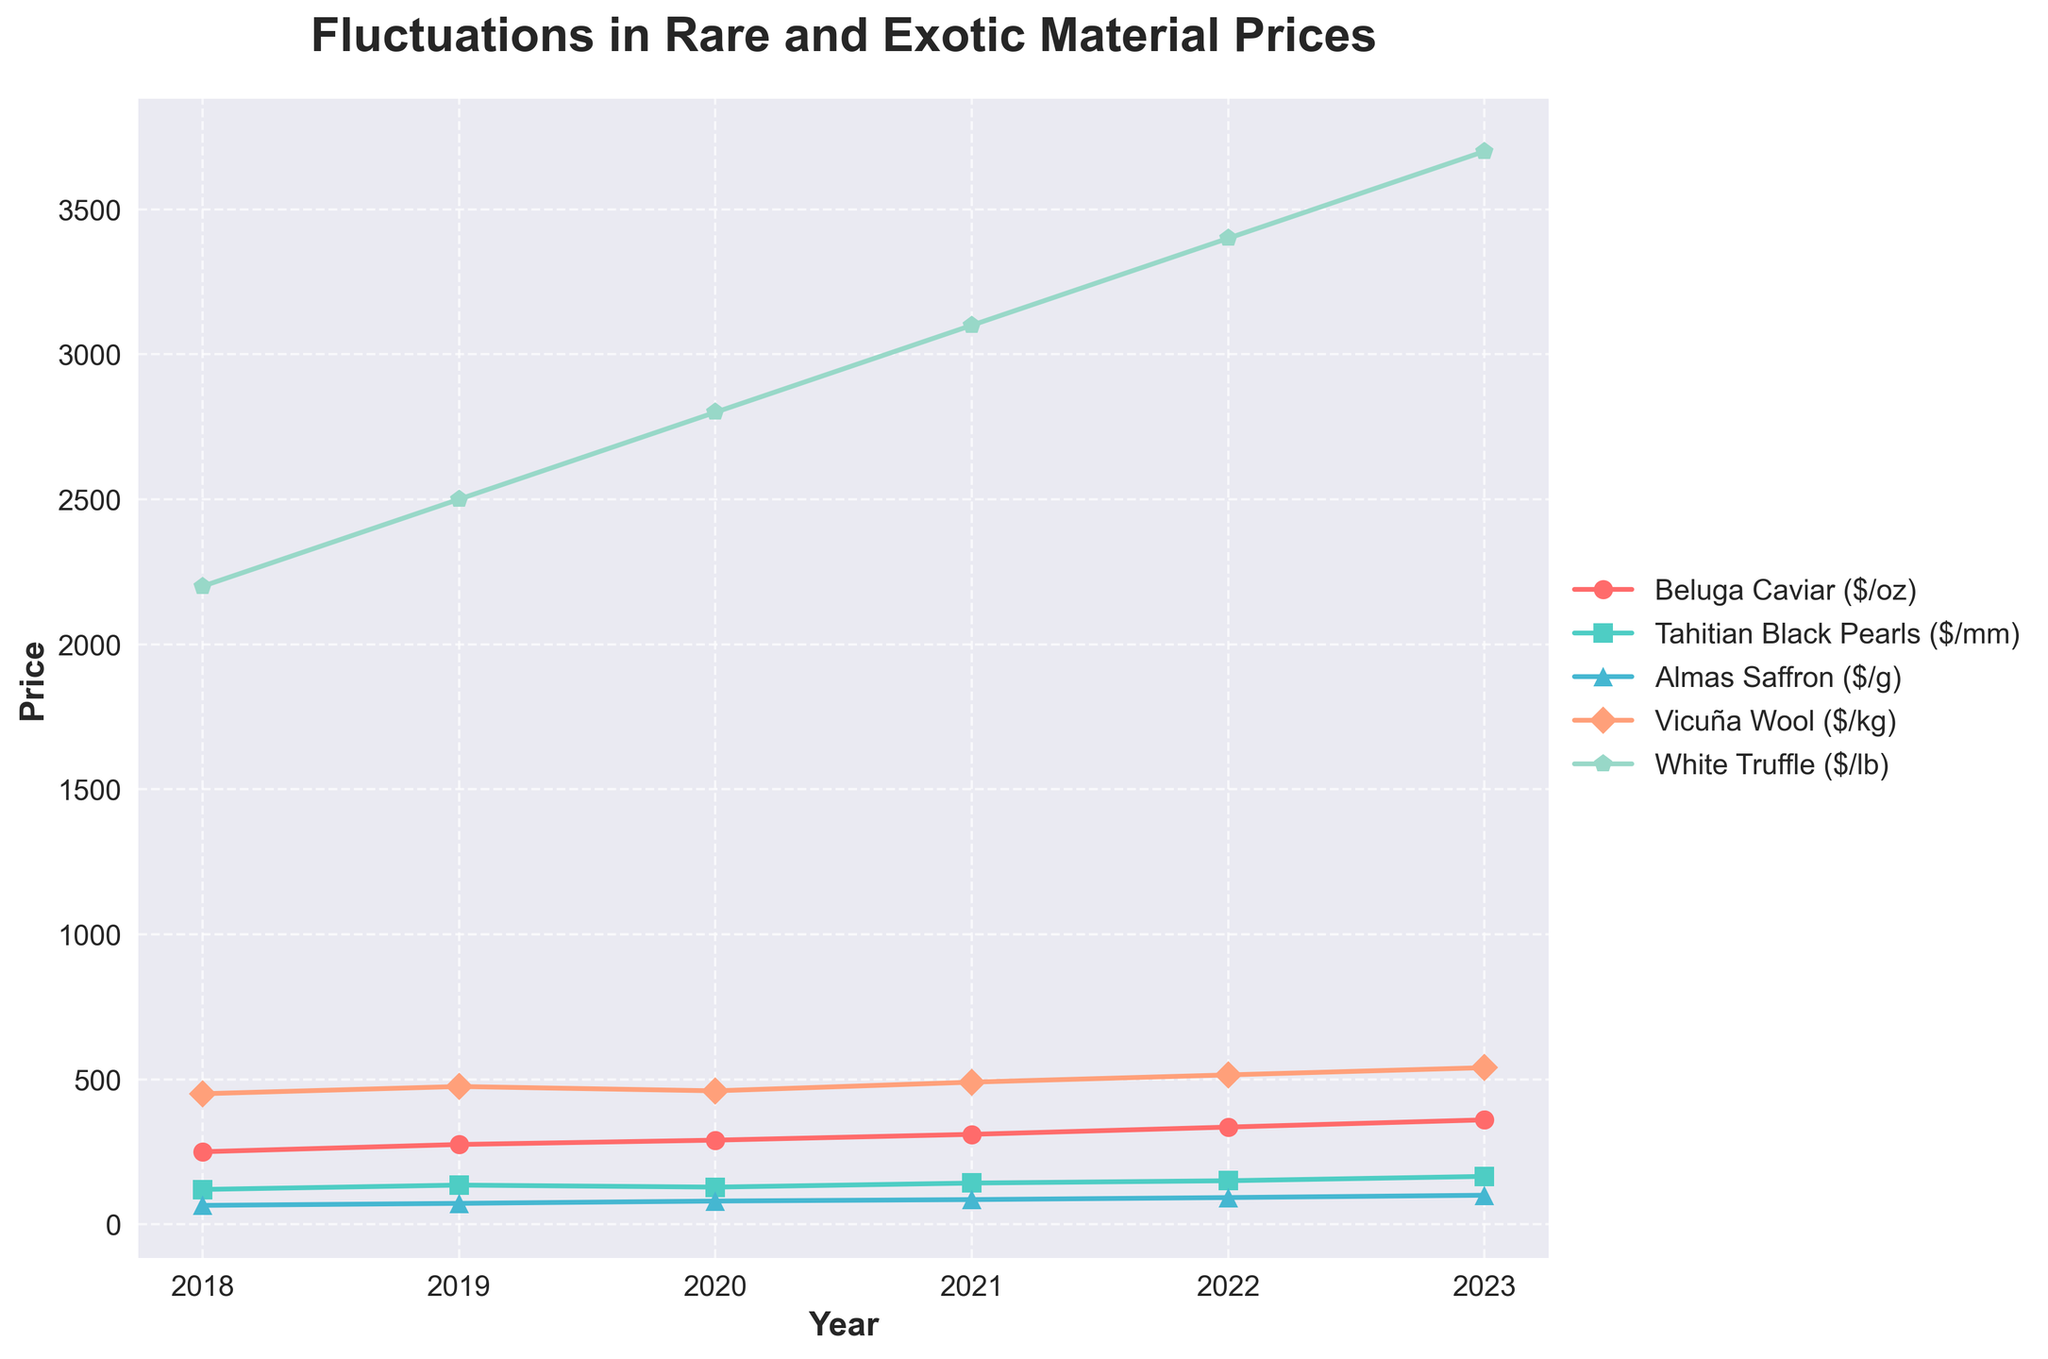What is the price trend of Tahitian Black Pearls from 2018 to 2023? Observe the line representing Tahitian Black Pearls. Note its movement starting from 120 in 2018 and ending at 165 in 2023, showing an upward trend.
Answer: Upward Which material had the highest price increase from 2018 to 2023? Calculate the price increase for each material by subtracting their 2018 prices from their 2023 prices. For Beluga Caviar, it's 360-250=110; Tahitian Black Pearls, 165-120=45; Almas Saffron, 100-65=35; Vicuña Wool, 540-450=90; White Truffle, 3700-2200=1500. White Truffle has the largest increase.
Answer: White Truffle In which year did Beluga Caviar price first exceed 300$/oz? Examine the line for Beluga Caviar and find when it crosses the 300$/oz mark. The price first exceeds 300$/oz in 2021.
Answer: 2021 Compare the price of Almas Saffron in 2021 and 2022. Which year is higher? Look at the points for Almas Saffron in 2021 and 2022. In 2021, the price is 85$/g, and in 2022, it is 92$/g.
Answer: 2022 Which year had the smallest price difference between Tahitian Black Pearls and Vicuña Wool? Calculate the differences for each year: 2018 (450-120=330), 2019 (475-135=340), 2020 (460-128=332), 2021 (490-142=348), 2022 (515-150=365), 2023 (540-165=375). The smallest difference is in 2018 with 330.
Answer: 2018 What is the average price of Beluga Caviar over the years 2020 to 2022? Add the prices from 2020, 2021, and 2022 (290 + 310 + 335) and divide by 3. 290 + 310 + 335 = 935; 935 / 3 = 311.67.
Answer: 311.67 By how much did White Truffle prices increase from 2019 to 2020? Subtract the 2019 price from the 2020 price for White Truffles: 2800 - 2500 = 300.
Answer: 300 Which material had the lowest price in 2020, and what was it? Find the lowest point on the graph for the year 2020. The lowest value is from Almas Saffron at 80$/g.
Answer: Almas Saffron, 80$/g 